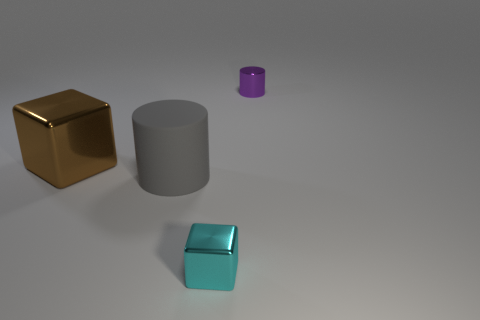What is the material of the cylinder left of the metallic object that is to the right of the small thing in front of the matte object?
Your answer should be very brief. Rubber. The small shiny thing in front of the large brown object is what color?
Make the answer very short. Cyan. Is there any other thing that has the same shape as the cyan metallic object?
Make the answer very short. Yes. What is the size of the metal thing that is in front of the shiny thing that is to the left of the small cyan shiny thing?
Your response must be concise. Small. Are there an equal number of tiny shiny cylinders in front of the gray cylinder and brown things behind the large brown object?
Offer a very short reply. Yes. Is there anything else that is the same size as the gray object?
Your answer should be compact. Yes. There is a cylinder that is made of the same material as the brown block; what is its color?
Keep it short and to the point. Purple. Do the gray thing and the cube in front of the big brown block have the same material?
Provide a succinct answer. No. There is a object that is both behind the gray cylinder and to the left of the shiny cylinder; what is its color?
Your answer should be very brief. Brown. What number of cubes are either tiny cyan things or tiny metal objects?
Offer a terse response. 1. 